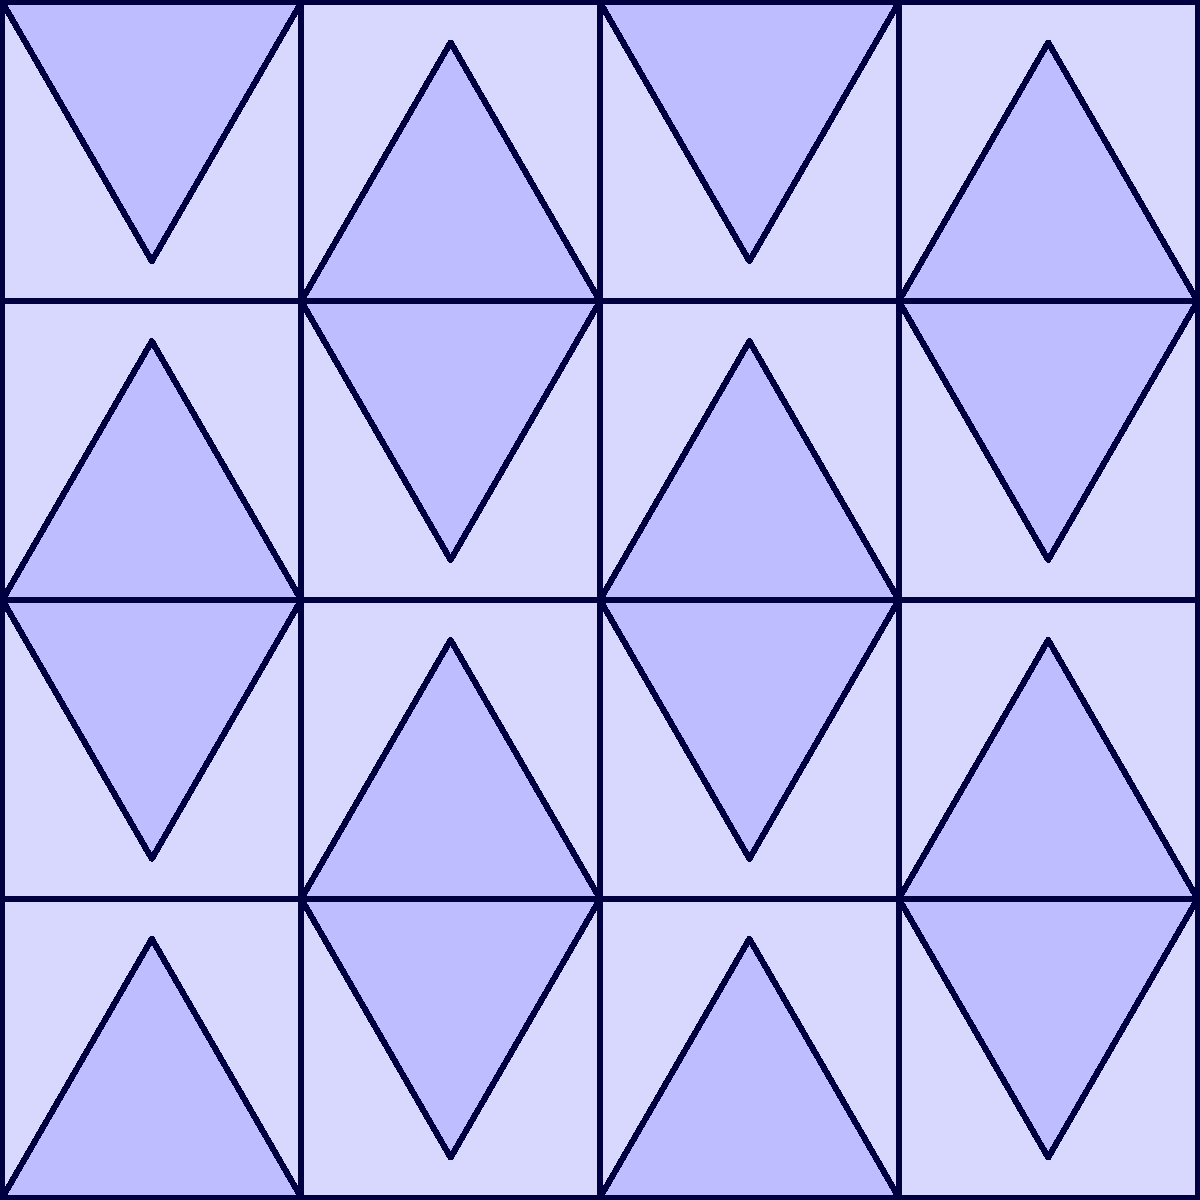Consider the geometric tile pattern shown above, which is commonly found in Islamic architecture. What is the order of the symmetry group for this pattern? To determine the order of the symmetry group, we need to identify all symmetry operations that leave the pattern unchanged. Let's analyze step-by-step:

1. Rotational symmetry:
   - 180° rotation about the center of each square: 2-fold rotation
   - 90° rotation about the center of the pattern: 4-fold rotation

2. Reflection symmetry:
   - Horizontal reflection through the middle
   - Vertical reflection through the middle
   - Two diagonal reflections (from corner to corner)

3. Translation symmetry:
   - The pattern repeats horizontally and vertically

The symmetry group of this pattern is known as p4m, which is a wallpaper group. To calculate its order:

- 4 rotations (0°, 90°, 180°, 270°)
- 4 reflections (horizontal, vertical, 2 diagonal)

The order of the symmetry group is the total number of unique symmetry operations:

$$ \text{Order} = 4 \text{ (rotations)} \times 2 \text{ (reflections)} = 8 $$

Therefore, the order of the symmetry group for this pattern is 8.
Answer: 8 